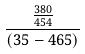Convert formula to latex. <formula><loc_0><loc_0><loc_500><loc_500>\frac { \frac { 3 8 0 } { 4 5 4 } } { ( 3 5 - 4 6 5 ) }</formula> 